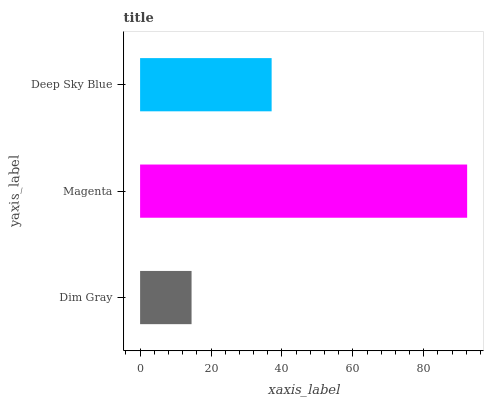Is Dim Gray the minimum?
Answer yes or no. Yes. Is Magenta the maximum?
Answer yes or no. Yes. Is Deep Sky Blue the minimum?
Answer yes or no. No. Is Deep Sky Blue the maximum?
Answer yes or no. No. Is Magenta greater than Deep Sky Blue?
Answer yes or no. Yes. Is Deep Sky Blue less than Magenta?
Answer yes or no. Yes. Is Deep Sky Blue greater than Magenta?
Answer yes or no. No. Is Magenta less than Deep Sky Blue?
Answer yes or no. No. Is Deep Sky Blue the high median?
Answer yes or no. Yes. Is Deep Sky Blue the low median?
Answer yes or no. Yes. Is Magenta the high median?
Answer yes or no. No. Is Dim Gray the low median?
Answer yes or no. No. 